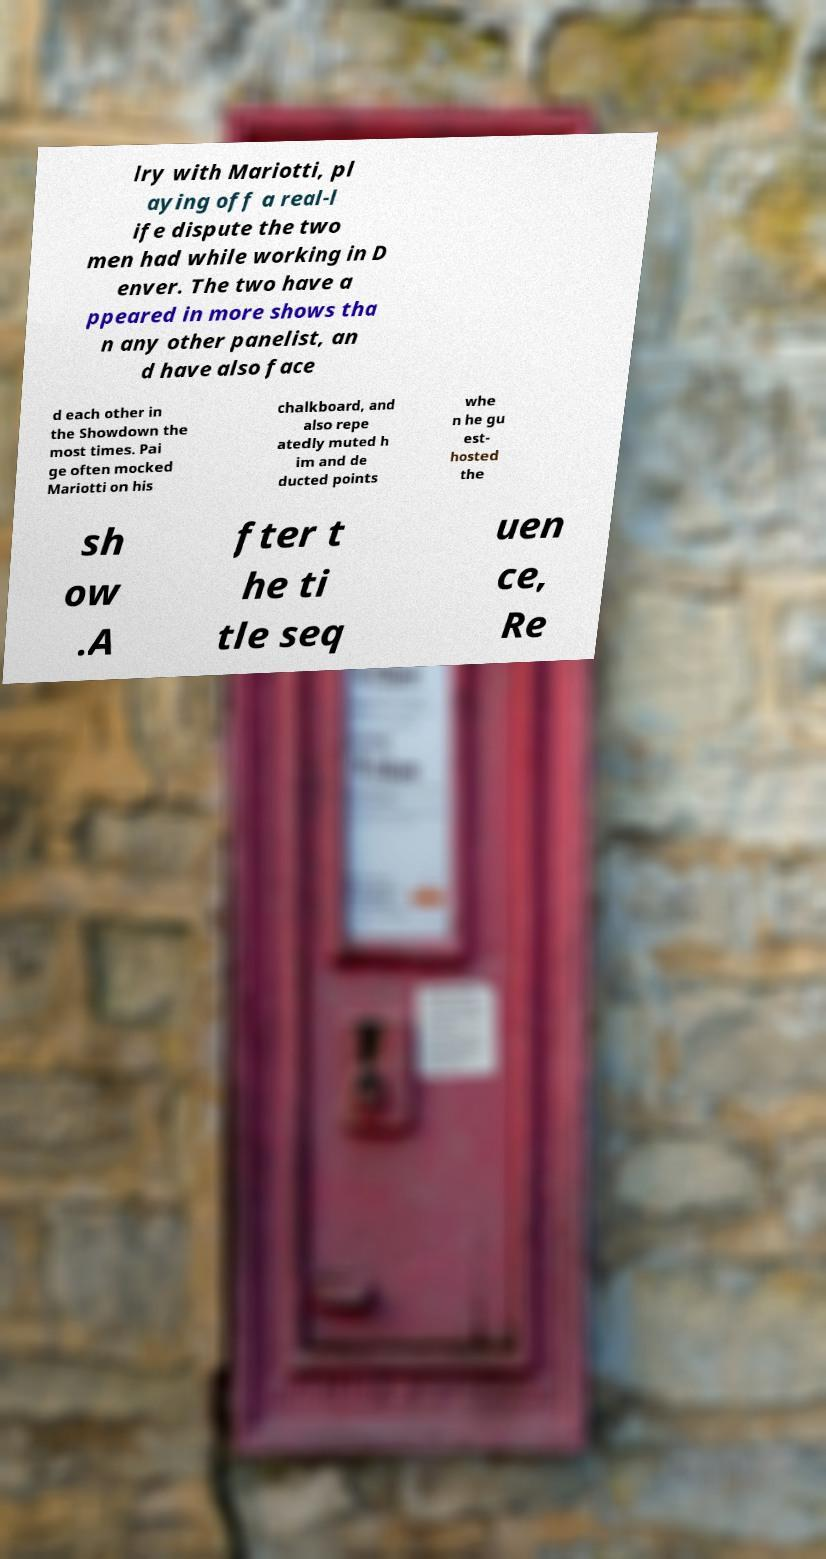Please identify and transcribe the text found in this image. lry with Mariotti, pl aying off a real-l ife dispute the two men had while working in D enver. The two have a ppeared in more shows tha n any other panelist, an d have also face d each other in the Showdown the most times. Pai ge often mocked Mariotti on his chalkboard, and also repe atedly muted h im and de ducted points whe n he gu est- hosted the sh ow .A fter t he ti tle seq uen ce, Re 